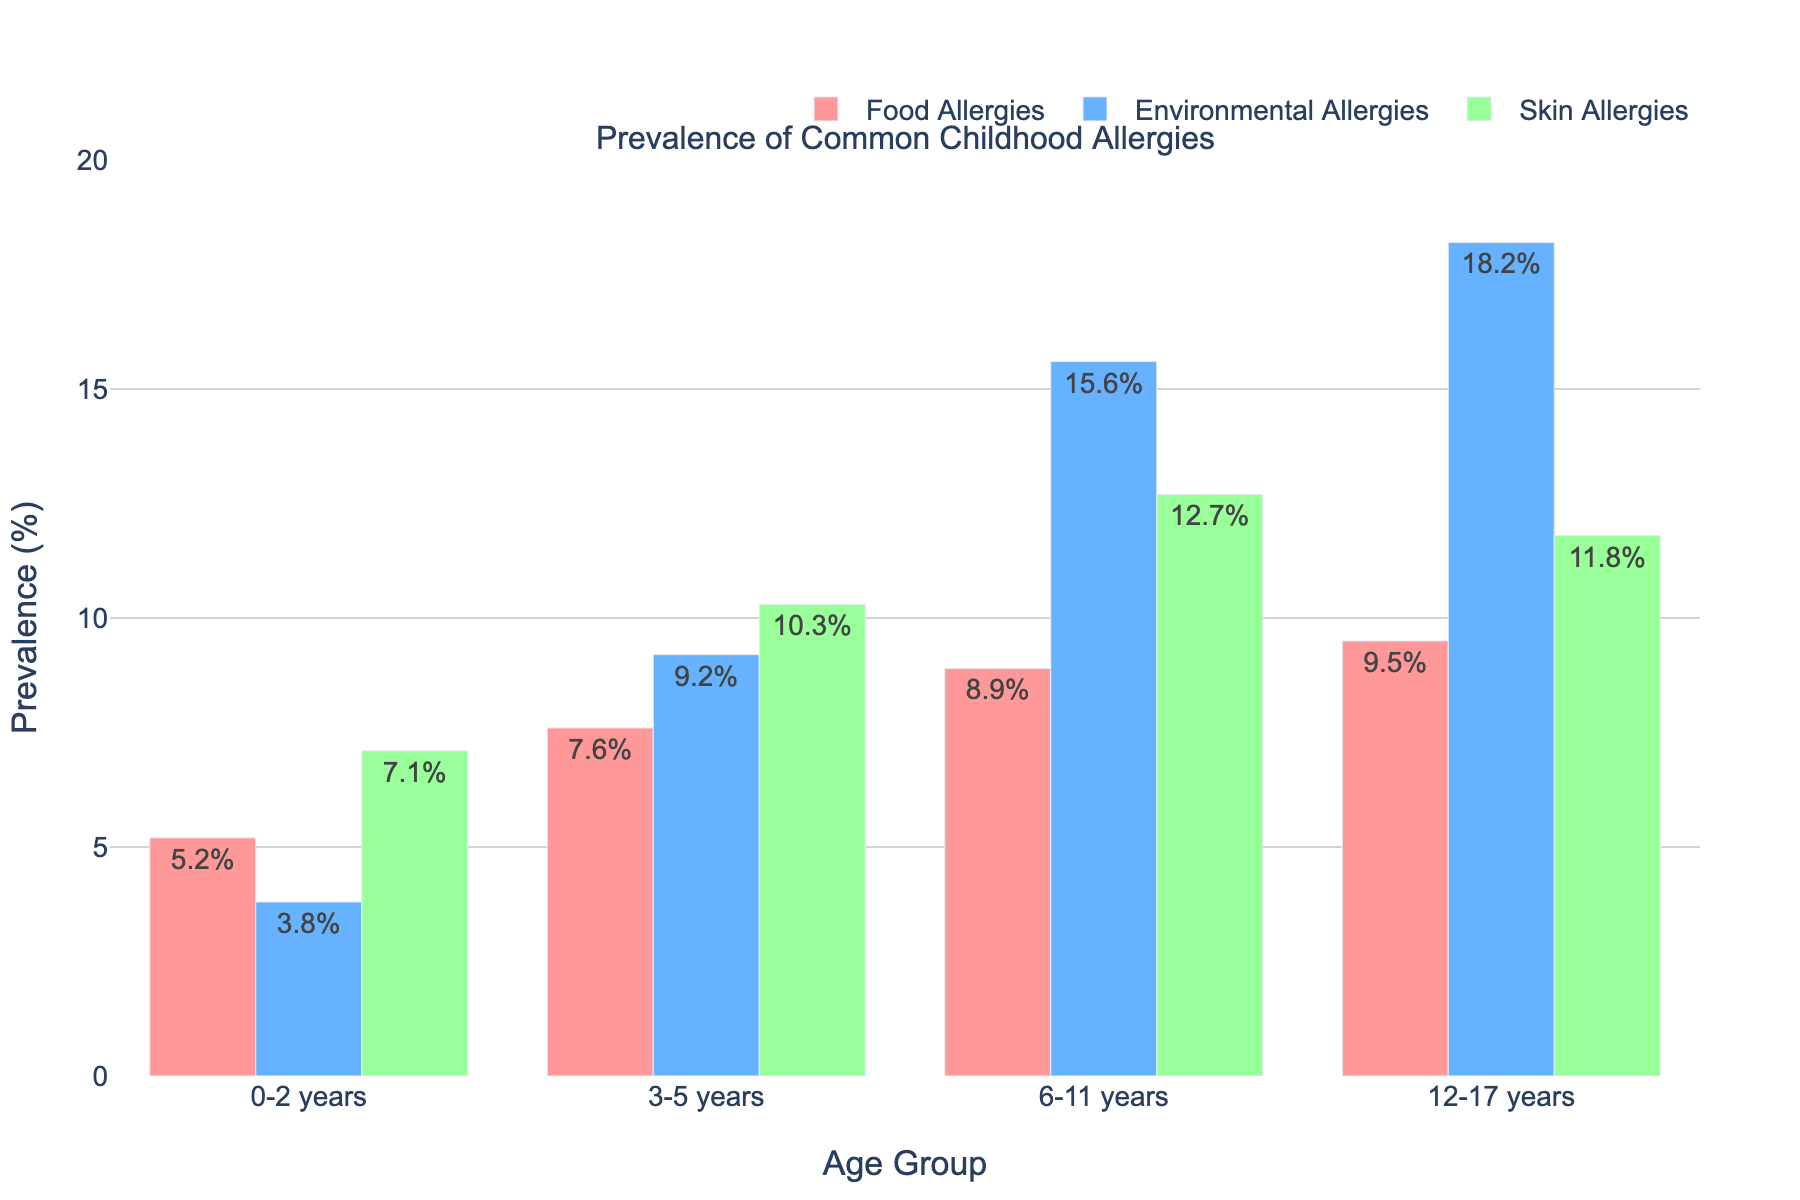Which age group has the highest prevalence of food allergies? The bar representing food allergies for the age group 12-17 years is the tallest among all age groups in the figure.
Answer: 12-17 years What's the difference in prevalence of environmental allergies between the age groups 12-17 years and 3-5 years? The prevalence of environmental allergies in the age group 12-17 years is 18.2% and in the age group 3-5 years is 9.2%. The difference is calculated by subtracting 9.2% from 18.2%.
Answer: 9% Which allergy type is most prevalent in the 6-11 years age group? In the 6-11 years age group, the bar for environmental allergies is higher than that for food allergies and skin allergies.
Answer: Environmental Allergies How does the prevalence of skin allergies in the 3-5 years age group compare to the 0-2 years age group? The prevalence of skin allergies in the 3-5 years age group is 10.3%, while in the 0-2 years age group it is 7.1%. The 3-5 years age group has a higher prevalence.
Answer: Higher Which age group has the lowest combined prevalence of all three allergy types? To find this, add the prevalence percentages of food, environmental, and skin allergies for each age group. For 0-2 years: 5.2 + 3.8 + 7.1 = 16.1%. For 3-5 years: 7.6 + 9.2 + 10.3 = 27.1%. For 6-11 years: 8.9 + 15.6 + 12.7 = 37.2%. For 12-17 years: 9.5 + 18.2 + 11.8 = 39.5%. Thus, the age group 0-2 years has the lowest combined prevalence.
Answer: 0-2 years Which allergy type shows the most significant increase in prevalence from the 0-2 years to the 12-17 years age group? The increase for each allergy type is calculated as follows: Food allergies: 9.5% - 5.2% = 4.3%, Environmental allergies: 18.2% - 3.8% = 14.4%, Skin allergies: 11.8% - 7.1% = 4.7%. Environmental allergies show the most significant increase.
Answer: Environmental Allergies What is the average prevalence of food allergies across all age groups? To find the average, sum the prevalence percentages of food allergies for all age groups and divide by the number of age groups: (5.2% + 7.6% + 8.9% + 9.5%) / 4 = 31.2% / 4.
Answer: 7.8% Are environmental allergies more prevalent than skin allergies in the 6-11 years age group? To determine this, compare the prevalence of environmental allergies (15.6%) to skin allergies (12.7%) in the 6-11 years age group. Environmental allergies are more prevalent.
Answer: Yes 